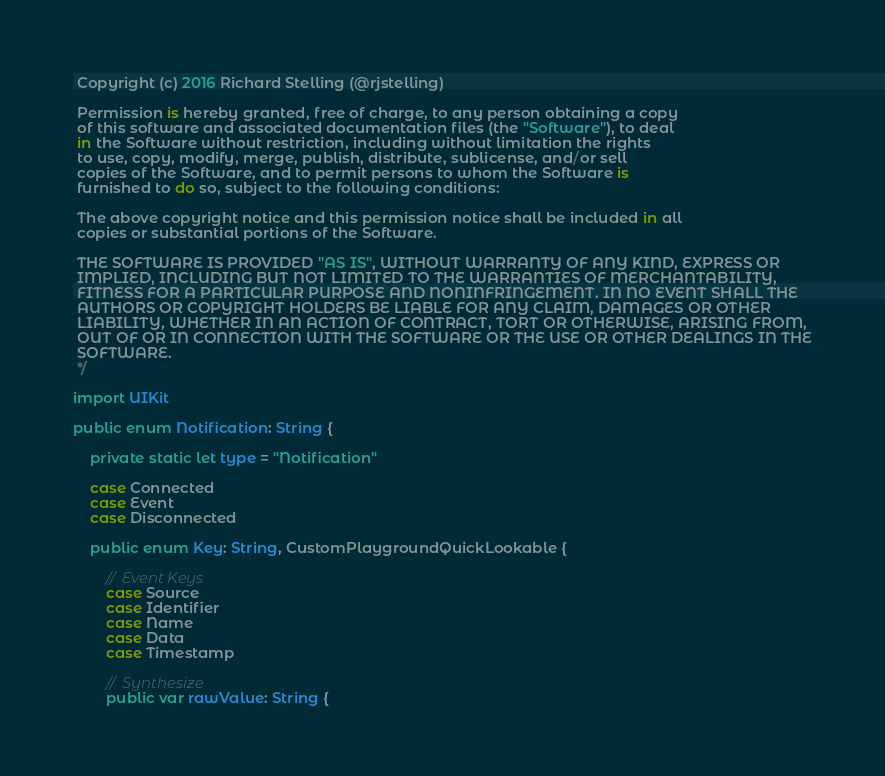Convert code to text. <code><loc_0><loc_0><loc_500><loc_500><_Swift_> Copyright (c) 2016 Richard Stelling (@rjstelling)
 
 Permission is hereby granted, free of charge, to any person obtaining a copy
 of this software and associated documentation files (the "Software"), to deal
 in the Software without restriction, including without limitation the rights
 to use, copy, modify, merge, publish, distribute, sublicense, and/or sell
 copies of the Software, and to permit persons to whom the Software is
 furnished to do so, subject to the following conditions:
 
 The above copyright notice and this permission notice shall be included in all
 copies or substantial portions of the Software.
 
 THE SOFTWARE IS PROVIDED "AS IS", WITHOUT WARRANTY OF ANY KIND, EXPRESS OR
 IMPLIED, INCLUDING BUT NOT LIMITED TO THE WARRANTIES OF MERCHANTABILITY,
 FITNESS FOR A PARTICULAR PURPOSE AND NONINFRINGEMENT. IN NO EVENT SHALL THE
 AUTHORS OR COPYRIGHT HOLDERS BE LIABLE FOR ANY CLAIM, DAMAGES OR OTHER
 LIABILITY, WHETHER IN AN ACTION OF CONTRACT, TORT OR OTHERWISE, ARISING FROM,
 OUT OF OR IN CONNECTION WITH THE SOFTWARE OR THE USE OR OTHER DEALINGS IN THE
 SOFTWARE.
 */

import UIKit

public enum Notification: String {
    
    private static let type = "Notification"
    
    case Connected
    case Event
    case Disconnected
    
    public enum Key: String, CustomPlaygroundQuickLookable {
        
        // Event Keys
        case Source
        case Identifier
        case Name
        case Data
        case Timestamp
        
        // Synthesize
        public var rawValue: String {</code> 